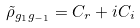<formula> <loc_0><loc_0><loc_500><loc_500>\tilde { \rho } _ { g _ { 1 } g _ { - 1 } } = C _ { r } + i C _ { i }</formula> 